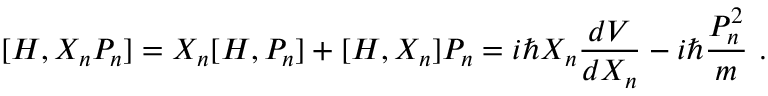<formula> <loc_0><loc_0><loc_500><loc_500>[ H , X _ { n } P _ { n } ] = X _ { n } [ H , P _ { n } ] + [ H , X _ { n } ] P _ { n } = i \hbar { X } _ { n } { \frac { d V } { d X _ { n } } } - i \hbar { \frac { P _ { n } ^ { 2 } } { m } } .</formula> 